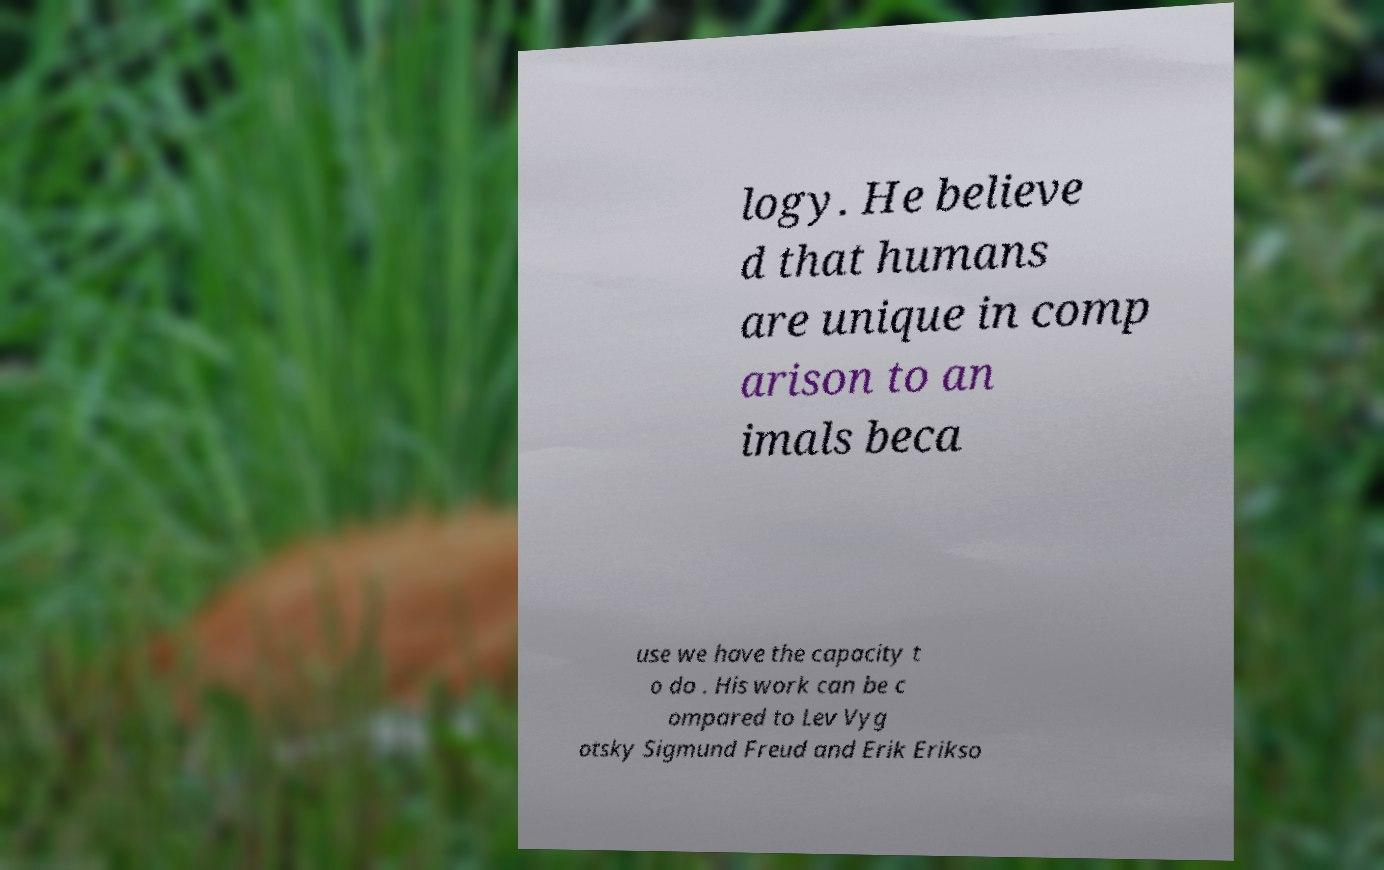Could you assist in decoding the text presented in this image and type it out clearly? logy. He believe d that humans are unique in comp arison to an imals beca use we have the capacity t o do . His work can be c ompared to Lev Vyg otsky Sigmund Freud and Erik Erikso 